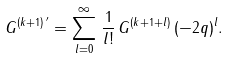<formula> <loc_0><loc_0><loc_500><loc_500>G ^ { ( k + 1 ) \, ^ { \prime } } = \sum _ { l = 0 } ^ { \infty } \, \frac { 1 } { l ! } \, G ^ { ( k + 1 + l ) } \, ( - 2 q ) ^ { l } .</formula> 